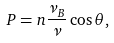Convert formula to latex. <formula><loc_0><loc_0><loc_500><loc_500>P = n \frac { \nu _ { B } } { \nu } \cos \theta ,</formula> 